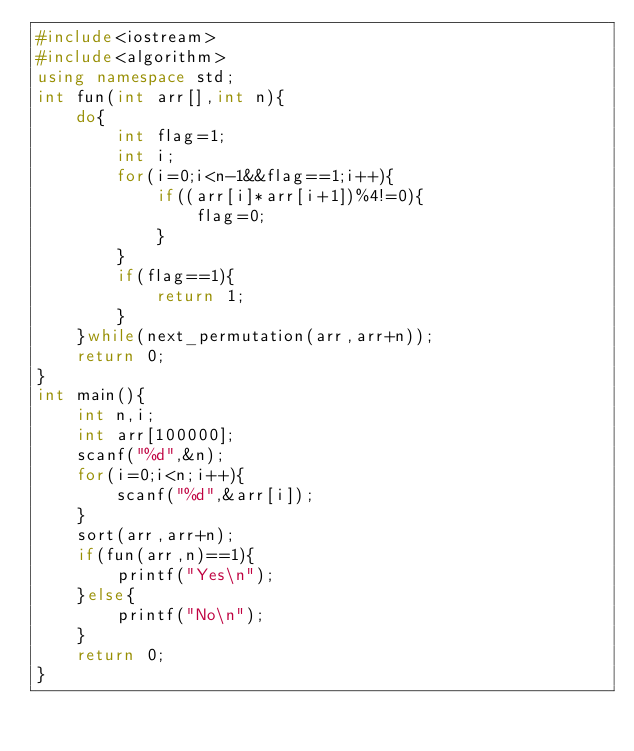<code> <loc_0><loc_0><loc_500><loc_500><_C++_>#include<iostream>
#include<algorithm>
using namespace std;
int fun(int arr[],int n){
	do{
		int flag=1;
		int i;
		for(i=0;i<n-1&&flag==1;i++){
			if((arr[i]*arr[i+1])%4!=0){
				flag=0;
			}
		}
		if(flag==1){
			return 1;
		}
	}while(next_permutation(arr,arr+n));
	return 0;
}
int main(){
	int n,i;
	int arr[100000];
	scanf("%d",&n);
	for(i=0;i<n;i++){
		scanf("%d",&arr[i]);
	}
	sort(arr,arr+n);
	if(fun(arr,n)==1){
		printf("Yes\n");
	}else{
		printf("No\n");
	}
	return 0;
}</code> 